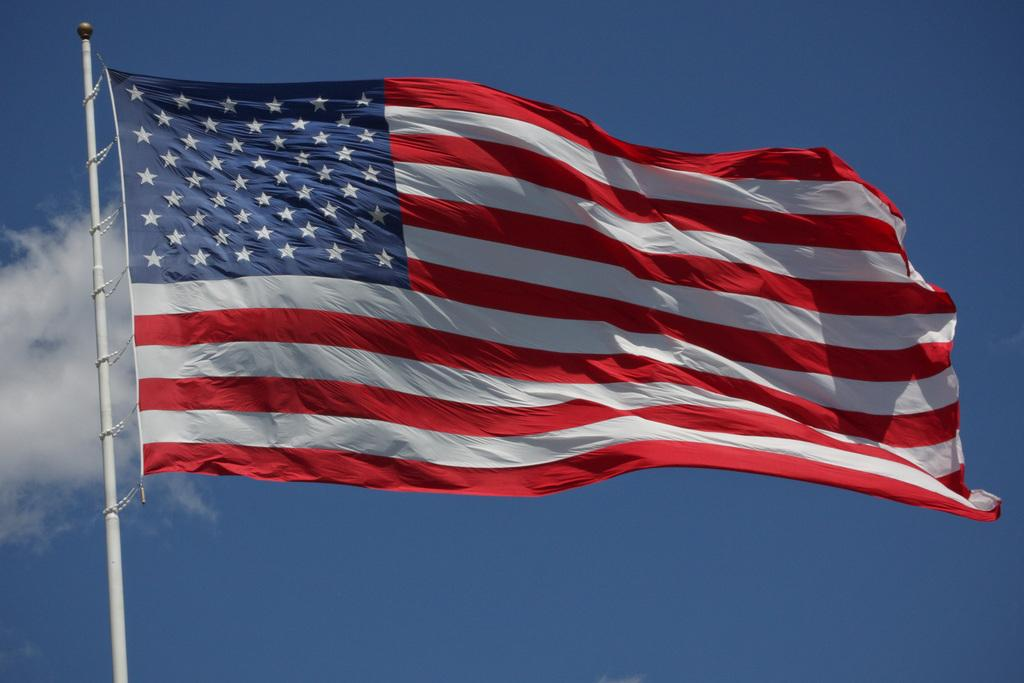What is the color of the pole in the image? The pole in the image is white-colored. What is attached to the pole? A flag is attached to the pole. What colors can be seen on the flag? The flag has blue, white, and red colors. What is visible in the background of the image? The sky is visible in the background of the image. Can you see any ghosts interacting with the flag in the image? There are no ghosts present in the image, and therefore no such interaction can be observed. 